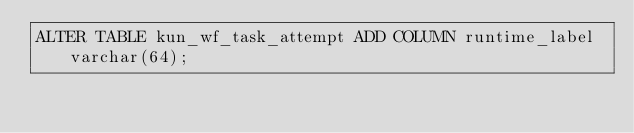Convert code to text. <code><loc_0><loc_0><loc_500><loc_500><_SQL_>ALTER TABLE kun_wf_task_attempt ADD COLUMN runtime_label varchar(64);</code> 